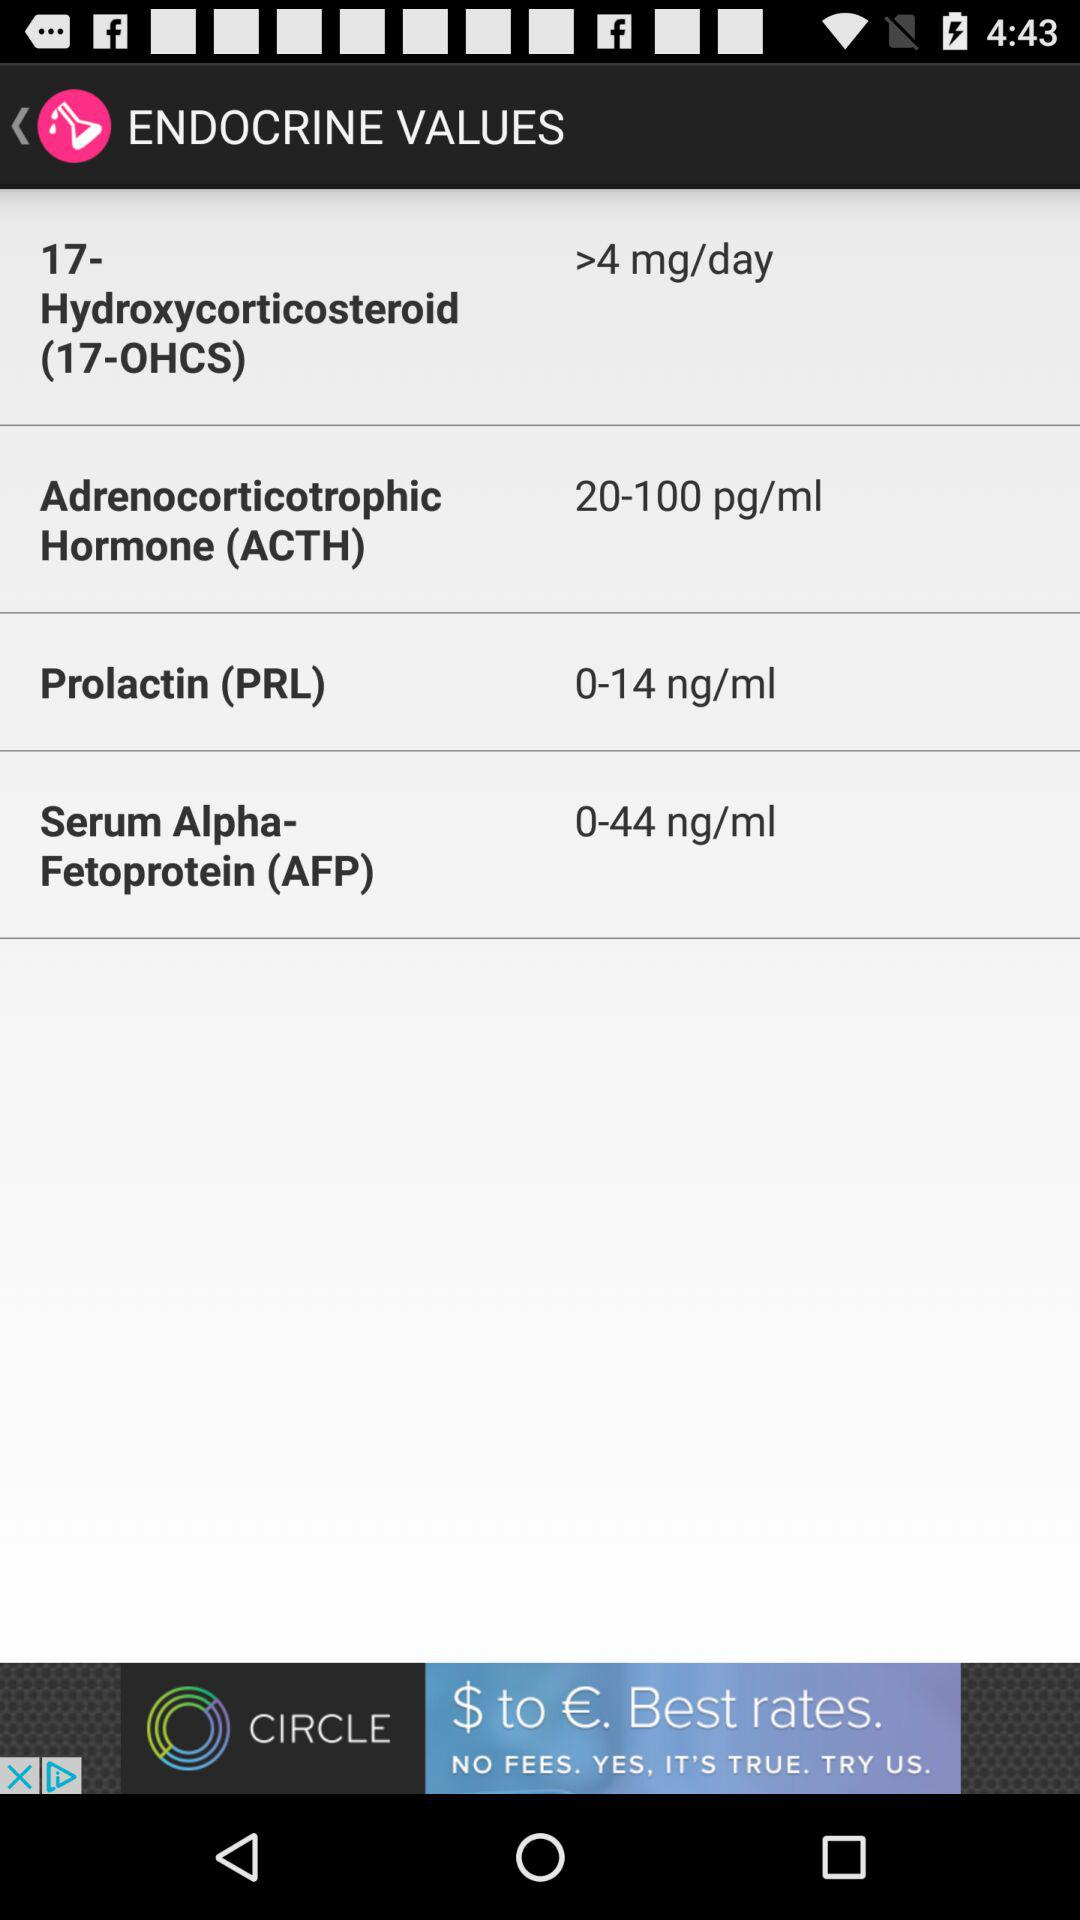How many units of prolactin is normal?
Answer the question using a single word or phrase. 0-14 ng/ml 